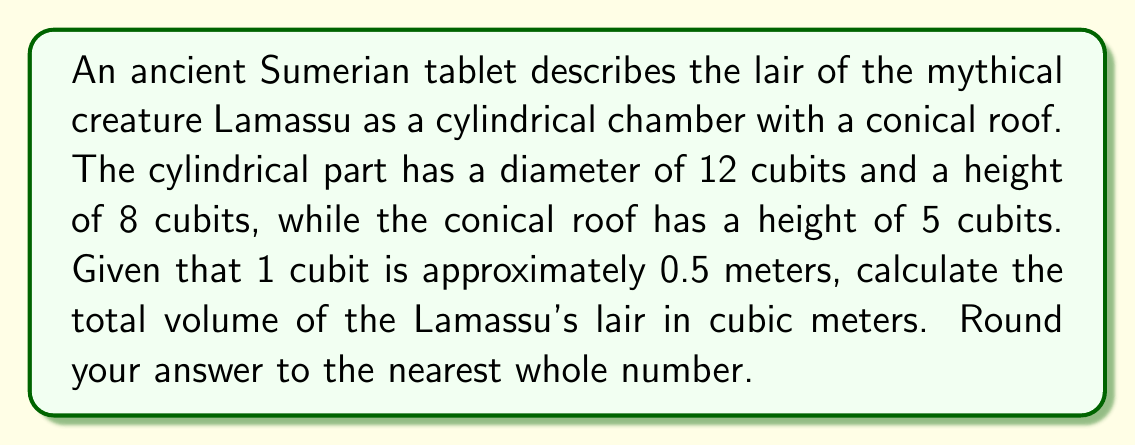Teach me how to tackle this problem. Let's break this down step-by-step:

1) First, we need to convert cubits to meters:
   Diameter = 12 cubits = 12 × 0.5 = 6 meters
   Cylinder height = 8 cubits = 8 × 0.5 = 4 meters
   Cone height = 5 cubits = 5 × 0.5 = 2.5 meters

2) Now, let's calculate the volume of the cylindrical part:
   $$V_{cylinder} = \pi r^2 h$$
   where $r$ is the radius (half the diameter) and $h$ is the height.
   $$V_{cylinder} = \pi (3m)^2 (4m) = 36\pi \text{ m}^3$$

3) Next, let's calculate the volume of the conical roof:
   $$V_{cone} = \frac{1}{3}\pi r^2 h$$
   $$V_{cone} = \frac{1}{3}\pi (3m)^2 (2.5m) = 7.5\pi \text{ m}^3$$

4) The total volume is the sum of these two parts:
   $$V_{total} = V_{cylinder} + V_{cone} = 36\pi \text{ m}^3 + 7.5\pi \text{ m}^3 = 43.5\pi \text{ m}^3$$

5) Let's calculate this:
   $$43.5\pi \approx 136.66 \text{ m}^3$$

6) Rounding to the nearest whole number:
   136.66 ≈ 137 m³
Answer: 137 m³ 